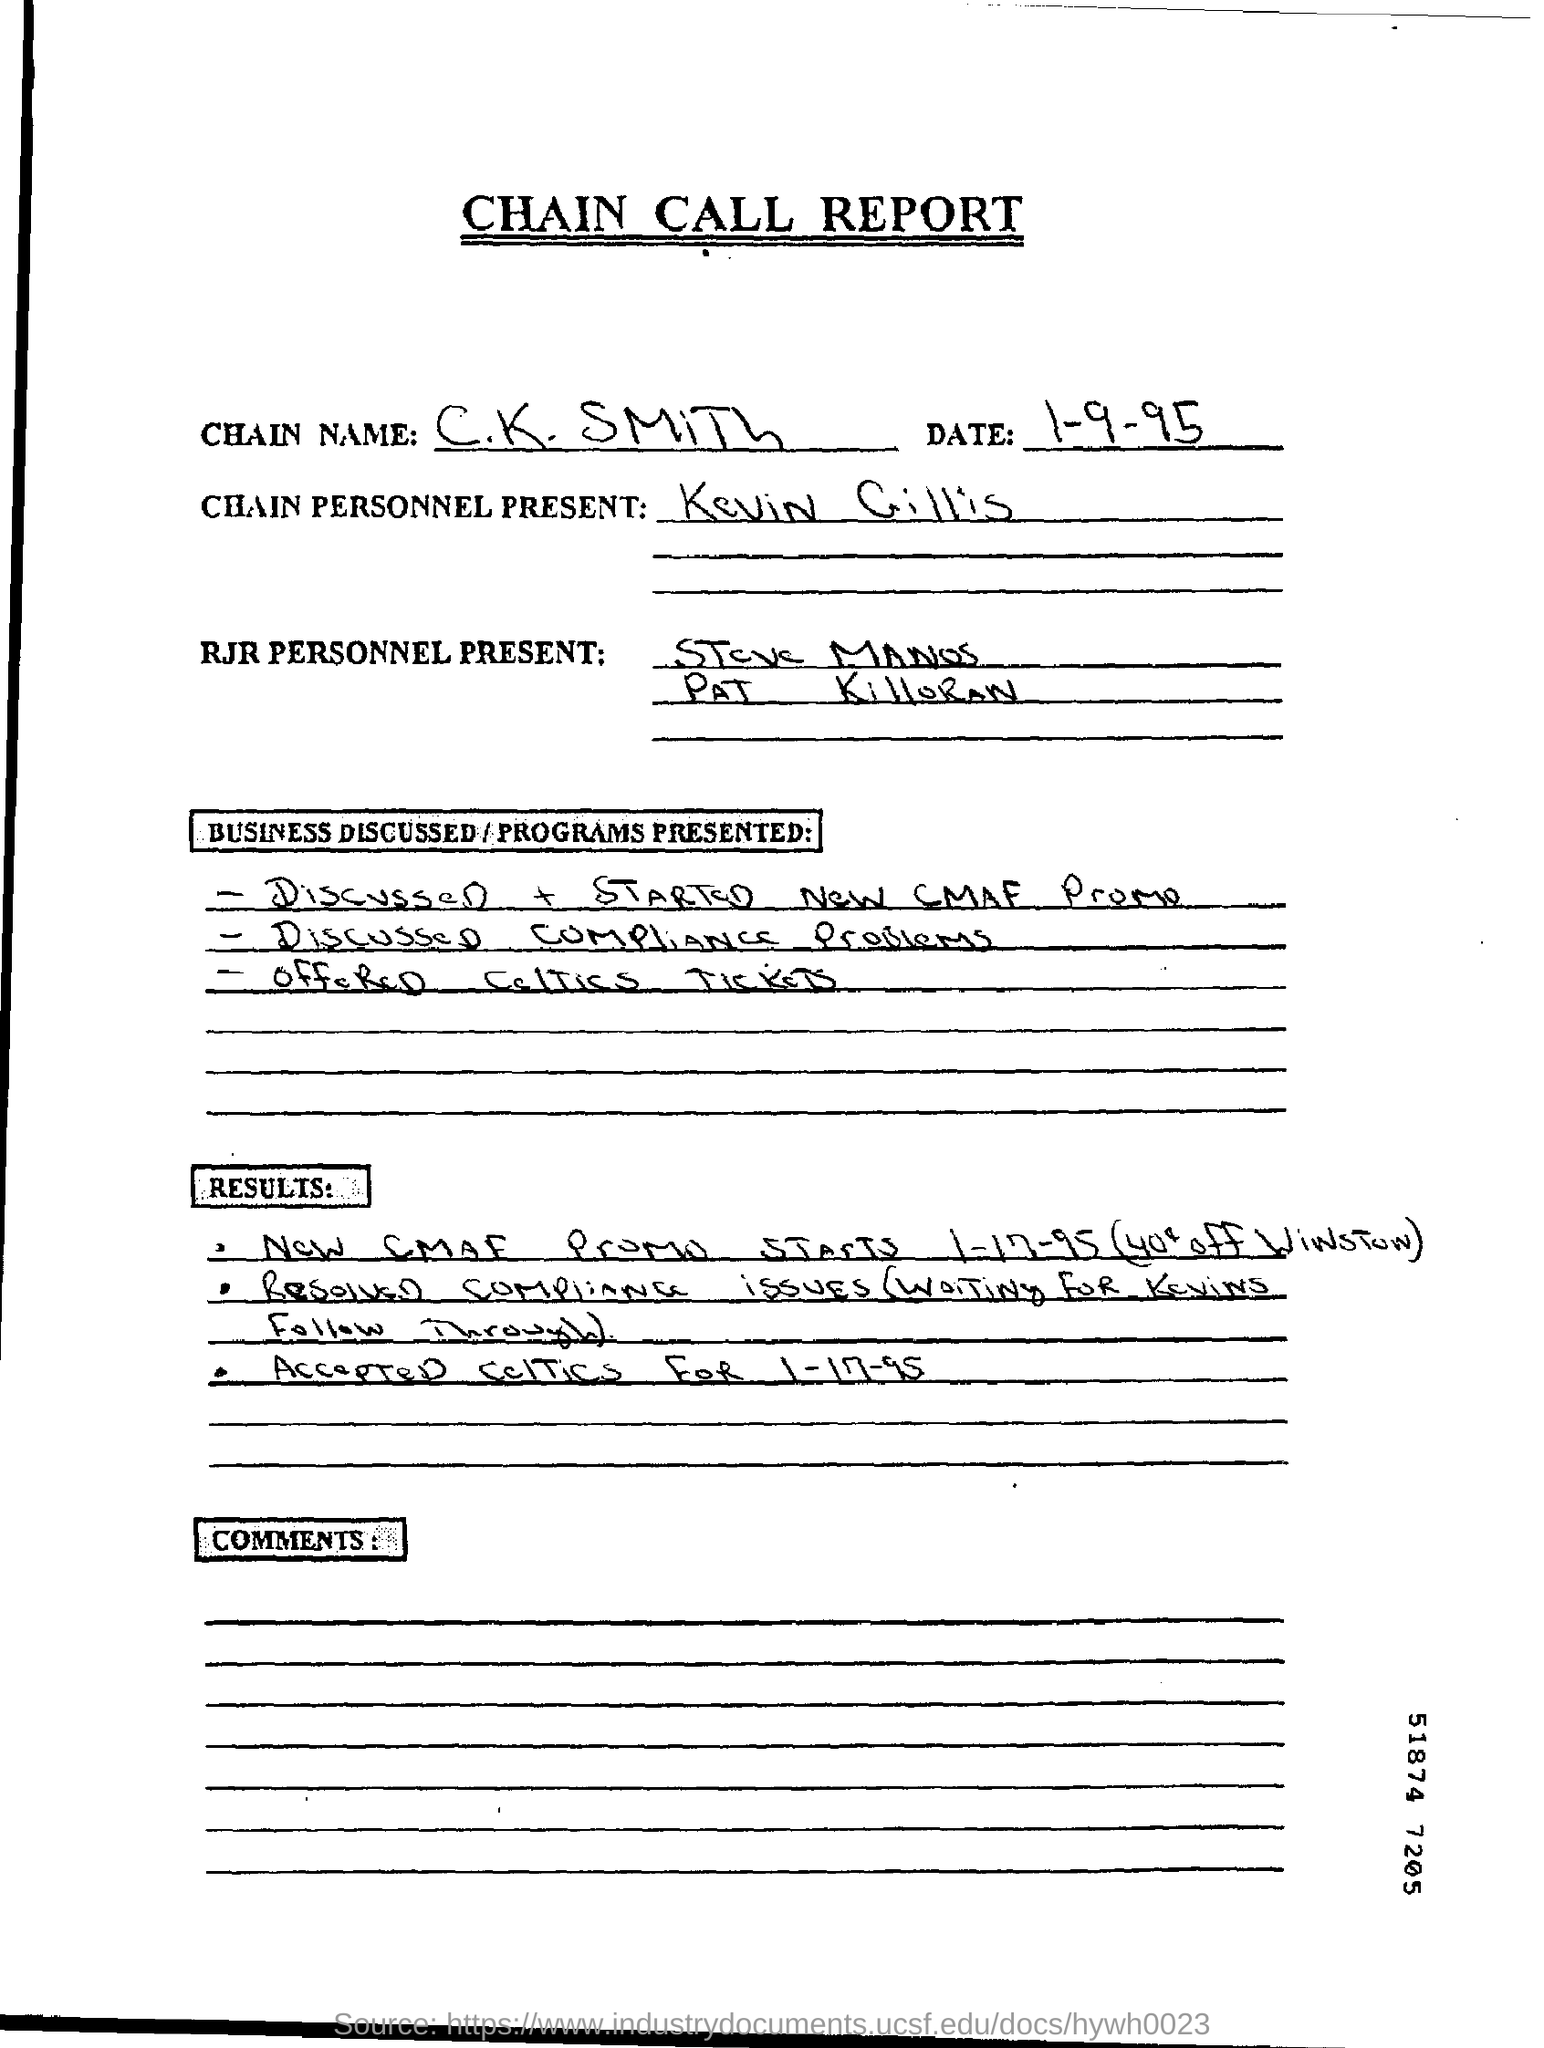What is the name of the report given ?
Your answer should be compact. CHAIN CALL REPORT. 